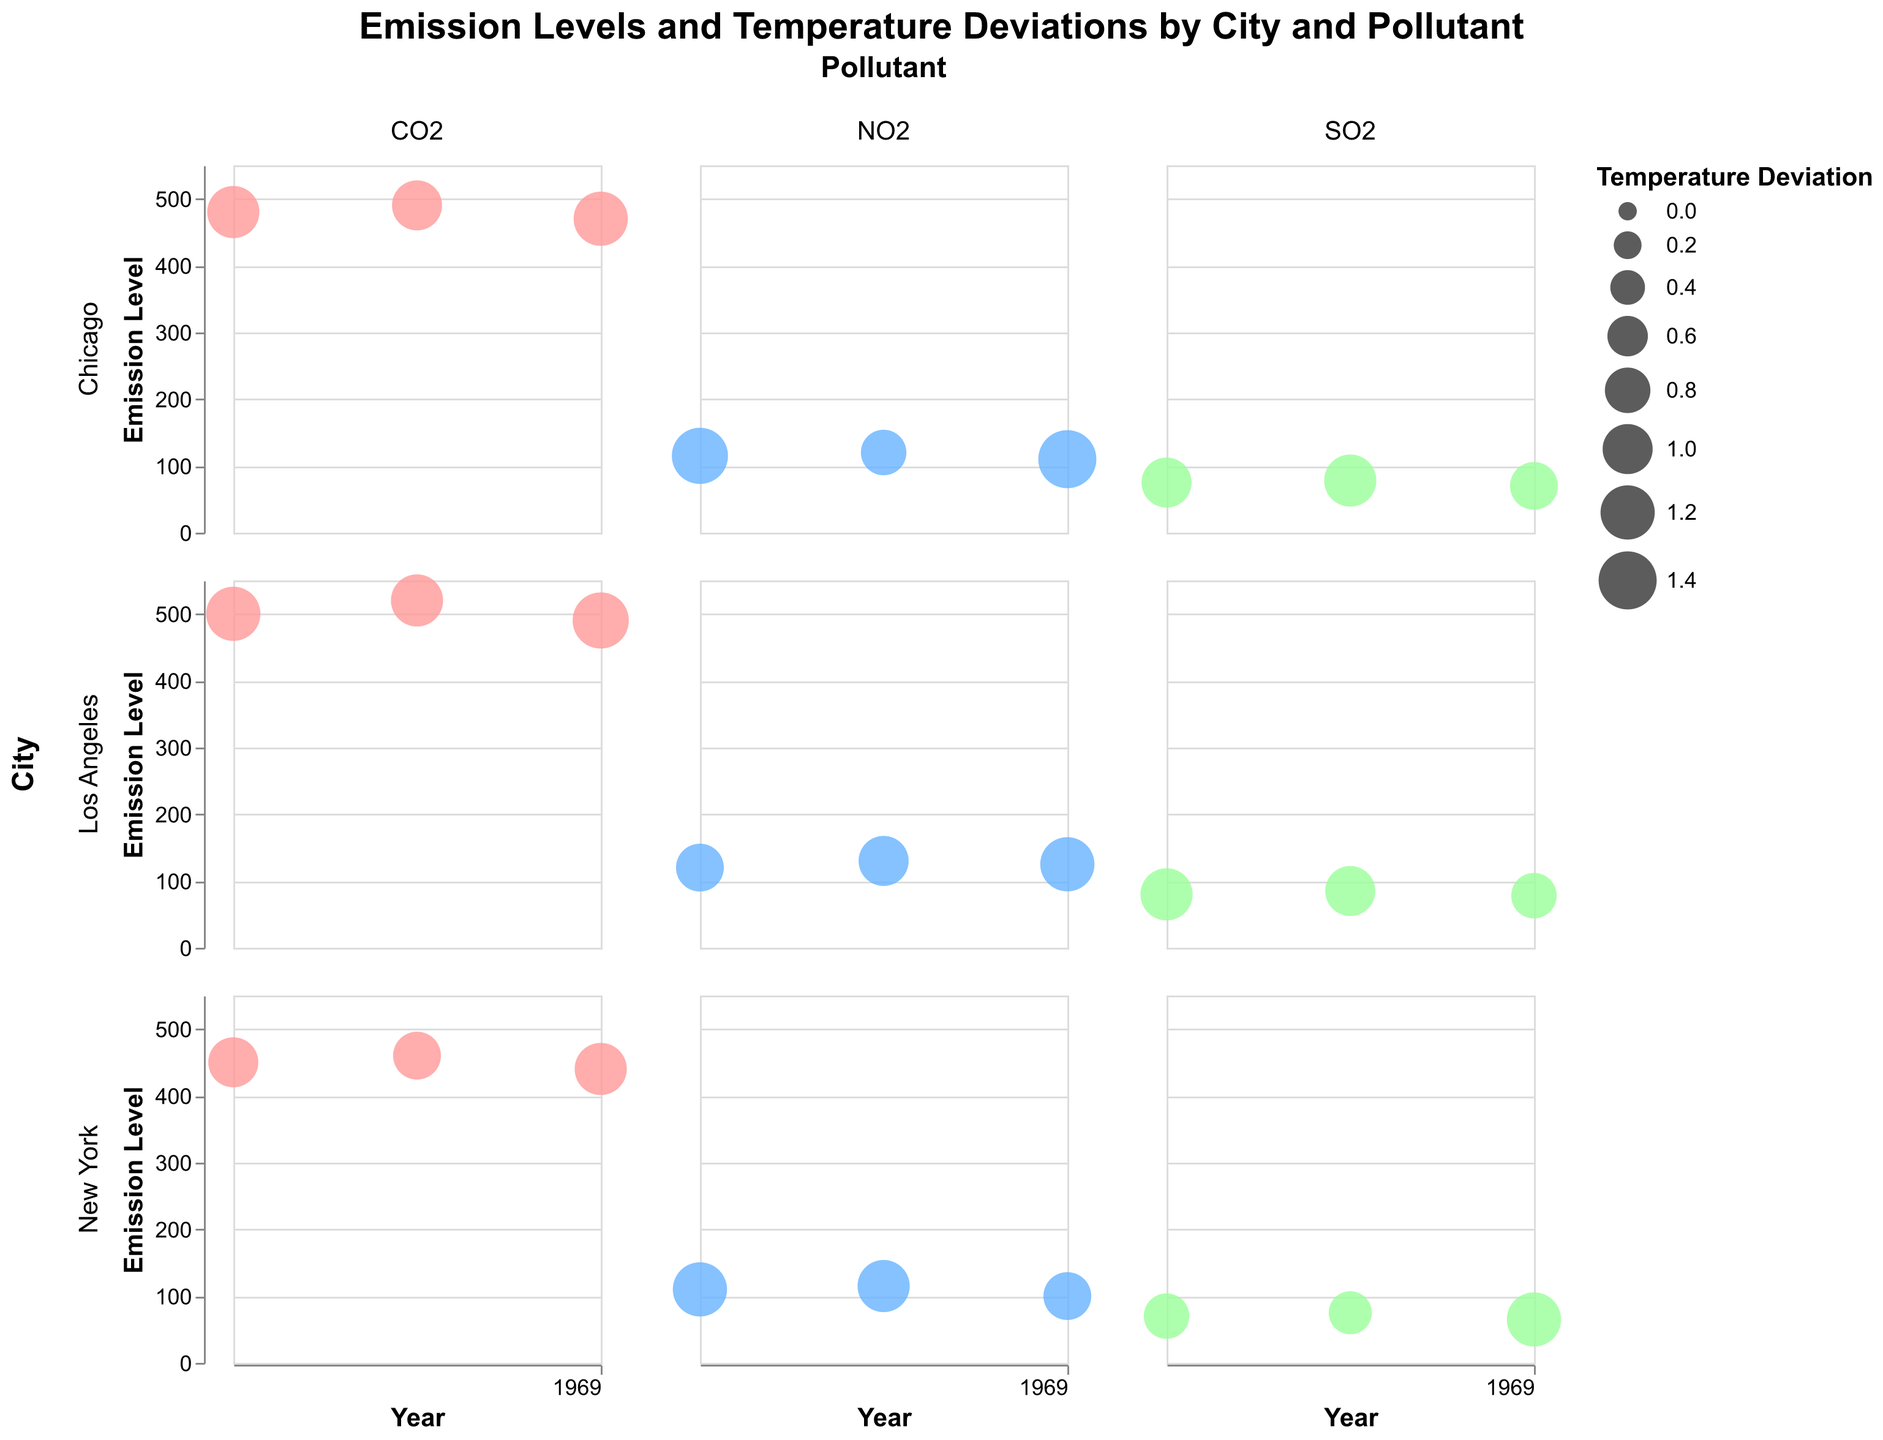What is the title of the figure? The title is usually positioned at the top of the figure, and in this case, it provides a summary of what the chart represents. Here, it reads "Emission Levels and Temperature Deviations by City and Pollutant".
Answer: Emission Levels and Temperature Deviations by City and Pollutant Which city and pollutant combination shows the highest CO2 emission level in 2019? To answer this, look at the CO2 emission levels for 2019 across all cities. The values are Los Angeles (520), New York (460), and Chicago (490). Therefore, Los Angeles has the highest emission level.
Answer: Los Angeles, CO2 How did the NO2 emission levels in New York change from 2018 to 2020? For New York, observe the NO2 emission levels in 2018 (110), 2019 (115), and 2020 (100). The emission level increased from 2018 to 2019 and then decreased in 2020.
Answer: Increased and then Decreased What is the trend of average temperature deviation for SO2 emissions in Chicago over the years? Check the bubble sizes for SO2 in Chicago, which serve as a proxy for average temperature deviations: 1.0 (2018), 1.1 (2019), and 0.9 (2020).
Answer: Slight increase from 2018 to 2019, then decrease in 2020 In which city and for which pollutant does the emission level decrease from 2018 to 2020? By checking all pollutant emission levels for each city from 2018 to 2020:
- Los Angeles: CO2 decreases, NO2 increases, and SO2 decreases.
- New York: CO2 and NO2 decrease, SO2 decreases.
- Chicago: CO2 decreases, NO2 decreases, and SO2 decreases.
Multiple cities and pollutants fit this criterion: CO2 in New York and Chicago, NO2 in New York, and SO2 in all cities.
Answer: CO2, New York and Chicago Compare the bubble size for NO2 in Los Angeles and Chicago in 2020. Which city had a higher temperature deviation? For 2020, look at the bubble sizes for NO2 in Los Angeles (1.2) and Chicago (1.4). As the bubble sizes directly reflect the temperature deviation, Chicago has a higher deviation.
Answer: Chicago What is the emission level difference for CO2 between Los Angeles and New York in 2020? CO2 emission levels in 2020: Los Angeles (490), New York (440). The difference is 490 - 440.
Answer: 50 Does any pollutant in any city show a consistent increase in emission levels from 2018 to 2020? Examine the trends for all pollutants in each city:
- Los Angeles: CO2 (decrease), NO2 (increase then decrease), SO2 (decrease).
- New York: CO2 (decrease), NO2 (increase then decrease), SO2 (decrease).
- Chicago: CO2, NO2, and SO2 all decrease over time.
None of the pollutants show a consistent increase.
Answer: No 